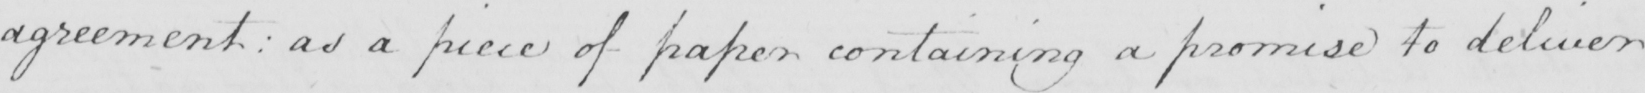Please transcribe the handwritten text in this image. agreement :  as a piece of paper containing a promise to deliver 